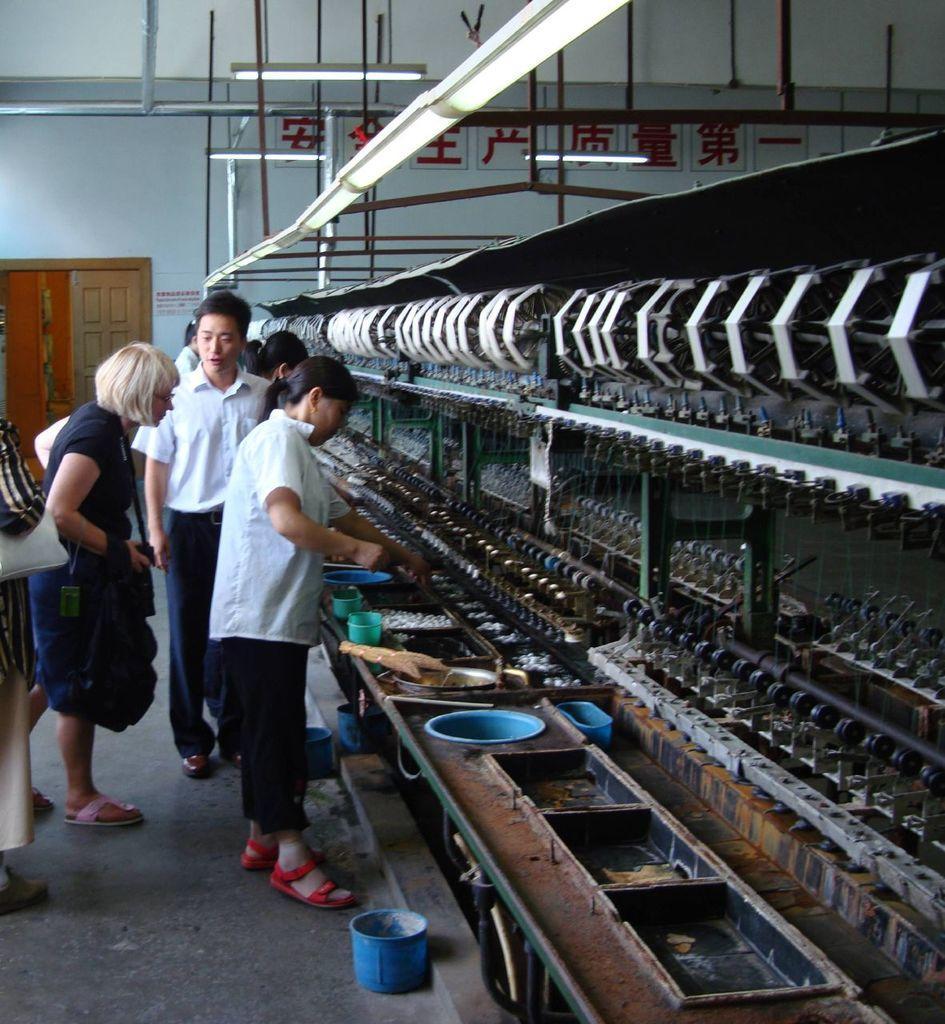Can you describe this image briefly? In the foreground I can see a group of people are standing on the floor in front of a table on which I can see bowls, boxes and a machine. In the background I can see a wall, rods, door. This image is taken may be in a factory outlet. 